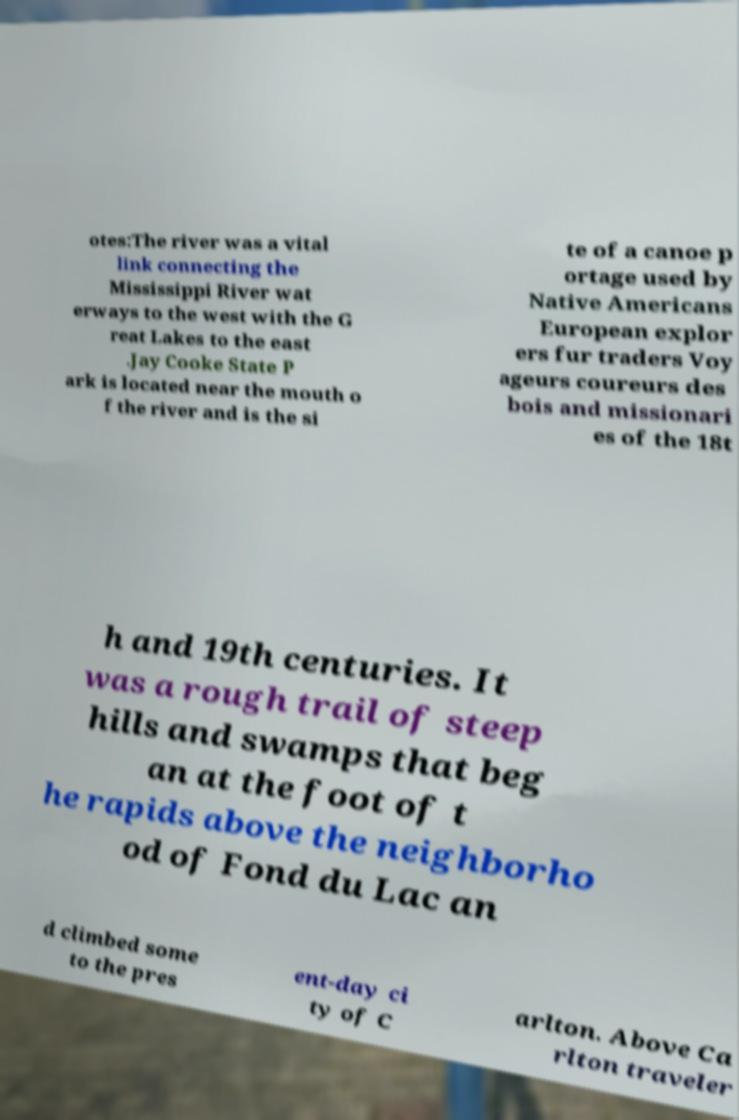There's text embedded in this image that I need extracted. Can you transcribe it verbatim? otes:The river was a vital link connecting the Mississippi River wat erways to the west with the G reat Lakes to the east .Jay Cooke State P ark is located near the mouth o f the river and is the si te of a canoe p ortage used by Native Americans European explor ers fur traders Voy ageurs coureurs des bois and missionari es of the 18t h and 19th centuries. It was a rough trail of steep hills and swamps that beg an at the foot of t he rapids above the neighborho od of Fond du Lac an d climbed some to the pres ent-day ci ty of C arlton. Above Ca rlton traveler 